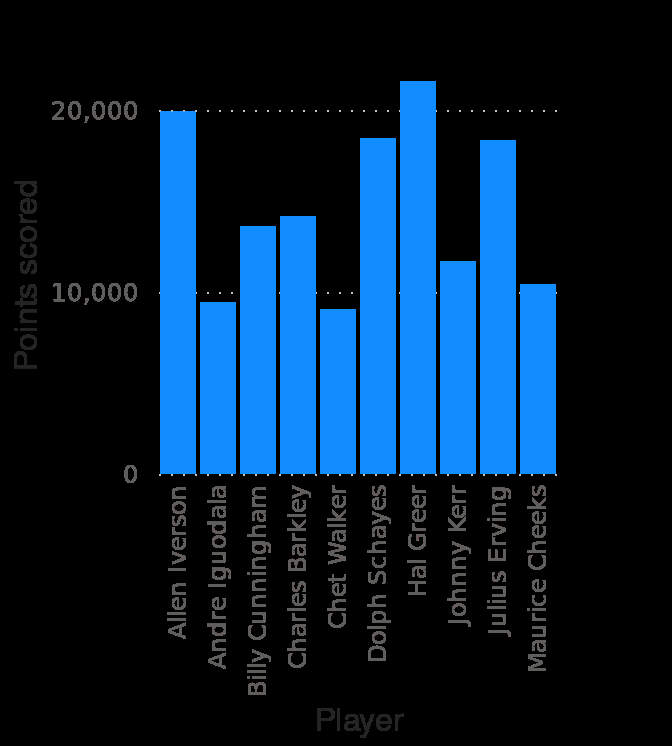<image>
What does this bar chart represent? This bar chart represents the all-time points leaders for the Philadelphia 76ers from 1949 to 2020. please enumerates aspects of the construction of the chart Philadelphia 76ers all-time points leaders from 1949 to 2020 is a bar chart. The x-axis shows Player along categorical scale with Allen Iverson on one end and  at the other while the y-axis plots Points scored using linear scale of range 0 to 20,000. Which player had the highest and lowest points in Philadelphia 76ers? Hal Greer had the highest points with over 20000, while Chet Walker had the lowest points at around 9000. How many points did Chet Walker score in Philadelphia 76ers?  He scored around 9000 points. What type of scale is used for the y-axis?  The y-axis uses a linear scale. Offer a thorough analysis of the image. Hal Greer had the highest points with over 20000. Chet Walker had the lowest points at around 9000 points in Philadelphia 76ers. 